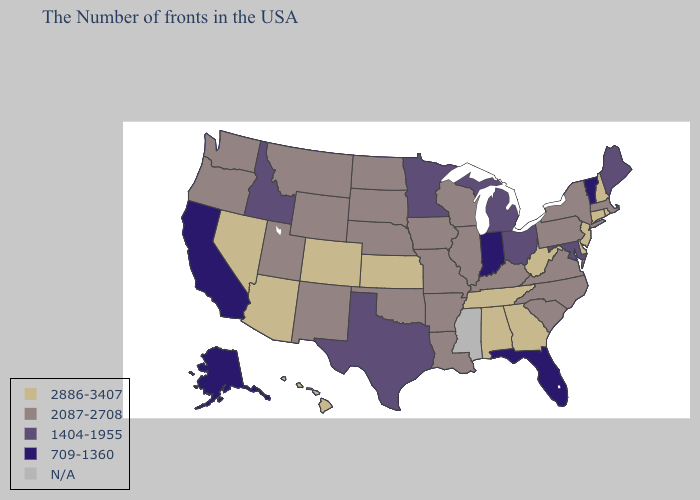Does Oklahoma have the highest value in the USA?
Keep it brief. No. Does the first symbol in the legend represent the smallest category?
Write a very short answer. No. What is the value of Pennsylvania?
Be succinct. 2087-2708. Does Nevada have the highest value in the West?
Be succinct. Yes. Does Oregon have the highest value in the USA?
Answer briefly. No. What is the value of Nevada?
Answer briefly. 2886-3407. Does New Hampshire have the lowest value in the USA?
Quick response, please. No. What is the highest value in states that border Michigan?
Quick response, please. 2087-2708. Name the states that have a value in the range N/A?
Give a very brief answer. Mississippi. Which states hav the highest value in the West?
Concise answer only. Colorado, Arizona, Nevada, Hawaii. Among the states that border Wyoming , which have the highest value?
Keep it brief. Colorado. What is the value of Ohio?
Quick response, please. 1404-1955. 